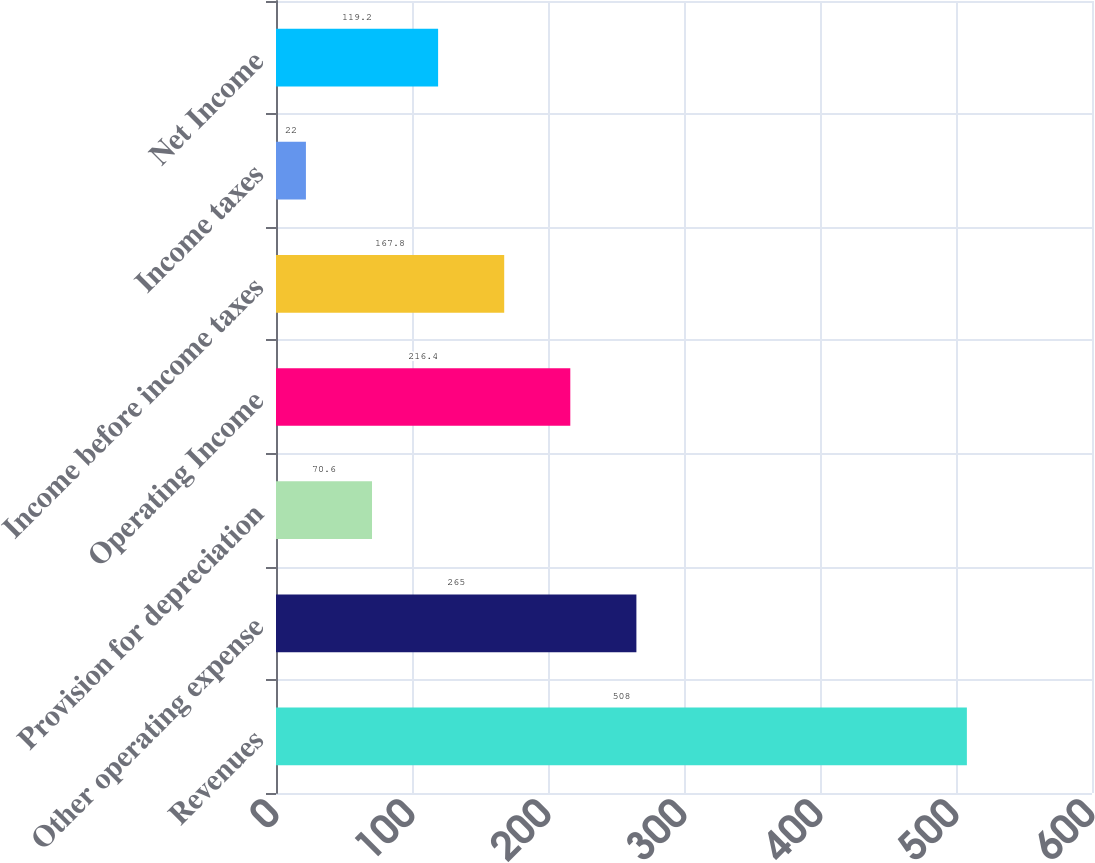Convert chart. <chart><loc_0><loc_0><loc_500><loc_500><bar_chart><fcel>Revenues<fcel>Other operating expense<fcel>Provision for depreciation<fcel>Operating Income<fcel>Income before income taxes<fcel>Income taxes<fcel>Net Income<nl><fcel>508<fcel>265<fcel>70.6<fcel>216.4<fcel>167.8<fcel>22<fcel>119.2<nl></chart> 